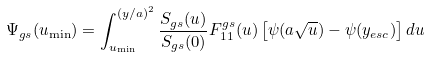Convert formula to latex. <formula><loc_0><loc_0><loc_500><loc_500>\Psi _ { g s } ( u _ { \min } ) = \int _ { u _ { \min } } ^ { ( y / a ) ^ { 2 } } \frac { S _ { g s } ( u ) } { S _ { g s } ( 0 ) } F ^ { g s } _ { 1 1 } ( u ) \left [ \psi ( a \sqrt { u } ) - \psi ( y _ { e s c } ) \right ] d u</formula> 